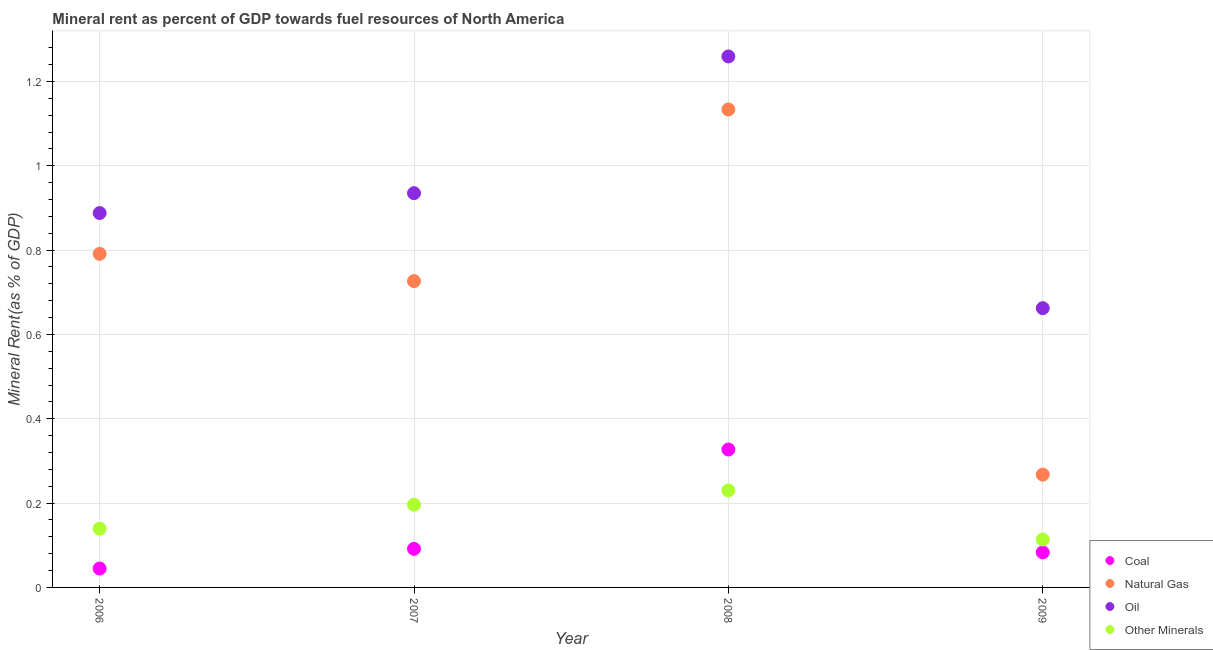What is the coal rent in 2008?
Your answer should be compact. 0.33. Across all years, what is the maximum coal rent?
Make the answer very short. 0.33. Across all years, what is the minimum  rent of other minerals?
Your response must be concise. 0.11. In which year was the natural gas rent minimum?
Keep it short and to the point. 2009. What is the total coal rent in the graph?
Provide a short and direct response. 0.55. What is the difference between the coal rent in 2006 and that in 2007?
Your answer should be very brief. -0.05. What is the difference between the coal rent in 2009 and the  rent of other minerals in 2008?
Provide a succinct answer. -0.15. What is the average coal rent per year?
Your answer should be very brief. 0.14. In the year 2009, what is the difference between the natural gas rent and oil rent?
Give a very brief answer. -0.39. In how many years, is the oil rent greater than 0.9600000000000001 %?
Your response must be concise. 1. What is the ratio of the oil rent in 2006 to that in 2009?
Your response must be concise. 1.34. Is the coal rent in 2006 less than that in 2009?
Provide a short and direct response. Yes. What is the difference between the highest and the second highest coal rent?
Ensure brevity in your answer.  0.24. What is the difference between the highest and the lowest oil rent?
Keep it short and to the point. 0.6. Is it the case that in every year, the sum of the coal rent and natural gas rent is greater than the sum of  rent of other minerals and oil rent?
Offer a terse response. No. Is it the case that in every year, the sum of the coal rent and natural gas rent is greater than the oil rent?
Your answer should be very brief. No. Is the coal rent strictly greater than the  rent of other minerals over the years?
Ensure brevity in your answer.  No. How many dotlines are there?
Ensure brevity in your answer.  4. How many years are there in the graph?
Offer a very short reply. 4. What is the title of the graph?
Make the answer very short. Mineral rent as percent of GDP towards fuel resources of North America. Does "European Union" appear as one of the legend labels in the graph?
Offer a very short reply. No. What is the label or title of the X-axis?
Your answer should be very brief. Year. What is the label or title of the Y-axis?
Provide a succinct answer. Mineral Rent(as % of GDP). What is the Mineral Rent(as % of GDP) of Coal in 2006?
Make the answer very short. 0.04. What is the Mineral Rent(as % of GDP) of Natural Gas in 2006?
Provide a short and direct response. 0.79. What is the Mineral Rent(as % of GDP) of Oil in 2006?
Ensure brevity in your answer.  0.89. What is the Mineral Rent(as % of GDP) in Other Minerals in 2006?
Make the answer very short. 0.14. What is the Mineral Rent(as % of GDP) in Coal in 2007?
Your response must be concise. 0.09. What is the Mineral Rent(as % of GDP) of Natural Gas in 2007?
Offer a very short reply. 0.73. What is the Mineral Rent(as % of GDP) of Oil in 2007?
Ensure brevity in your answer.  0.93. What is the Mineral Rent(as % of GDP) of Other Minerals in 2007?
Make the answer very short. 0.2. What is the Mineral Rent(as % of GDP) in Coal in 2008?
Offer a terse response. 0.33. What is the Mineral Rent(as % of GDP) of Natural Gas in 2008?
Give a very brief answer. 1.13. What is the Mineral Rent(as % of GDP) in Oil in 2008?
Make the answer very short. 1.26. What is the Mineral Rent(as % of GDP) of Other Minerals in 2008?
Offer a very short reply. 0.23. What is the Mineral Rent(as % of GDP) of Coal in 2009?
Provide a succinct answer. 0.08. What is the Mineral Rent(as % of GDP) of Natural Gas in 2009?
Your answer should be very brief. 0.27. What is the Mineral Rent(as % of GDP) of Oil in 2009?
Offer a terse response. 0.66. What is the Mineral Rent(as % of GDP) of Other Minerals in 2009?
Offer a terse response. 0.11. Across all years, what is the maximum Mineral Rent(as % of GDP) in Coal?
Offer a terse response. 0.33. Across all years, what is the maximum Mineral Rent(as % of GDP) in Natural Gas?
Offer a very short reply. 1.13. Across all years, what is the maximum Mineral Rent(as % of GDP) of Oil?
Your response must be concise. 1.26. Across all years, what is the maximum Mineral Rent(as % of GDP) of Other Minerals?
Offer a terse response. 0.23. Across all years, what is the minimum Mineral Rent(as % of GDP) in Coal?
Ensure brevity in your answer.  0.04. Across all years, what is the minimum Mineral Rent(as % of GDP) in Natural Gas?
Give a very brief answer. 0.27. Across all years, what is the minimum Mineral Rent(as % of GDP) of Oil?
Keep it short and to the point. 0.66. Across all years, what is the minimum Mineral Rent(as % of GDP) in Other Minerals?
Give a very brief answer. 0.11. What is the total Mineral Rent(as % of GDP) of Coal in the graph?
Your answer should be compact. 0.55. What is the total Mineral Rent(as % of GDP) in Natural Gas in the graph?
Offer a very short reply. 2.92. What is the total Mineral Rent(as % of GDP) in Oil in the graph?
Offer a very short reply. 3.74. What is the total Mineral Rent(as % of GDP) in Other Minerals in the graph?
Your response must be concise. 0.68. What is the difference between the Mineral Rent(as % of GDP) in Coal in 2006 and that in 2007?
Your response must be concise. -0.05. What is the difference between the Mineral Rent(as % of GDP) in Natural Gas in 2006 and that in 2007?
Offer a terse response. 0.06. What is the difference between the Mineral Rent(as % of GDP) of Oil in 2006 and that in 2007?
Your answer should be very brief. -0.05. What is the difference between the Mineral Rent(as % of GDP) in Other Minerals in 2006 and that in 2007?
Keep it short and to the point. -0.06. What is the difference between the Mineral Rent(as % of GDP) in Coal in 2006 and that in 2008?
Offer a very short reply. -0.28. What is the difference between the Mineral Rent(as % of GDP) in Natural Gas in 2006 and that in 2008?
Provide a short and direct response. -0.34. What is the difference between the Mineral Rent(as % of GDP) in Oil in 2006 and that in 2008?
Your response must be concise. -0.37. What is the difference between the Mineral Rent(as % of GDP) of Other Minerals in 2006 and that in 2008?
Provide a short and direct response. -0.09. What is the difference between the Mineral Rent(as % of GDP) in Coal in 2006 and that in 2009?
Your answer should be very brief. -0.04. What is the difference between the Mineral Rent(as % of GDP) in Natural Gas in 2006 and that in 2009?
Offer a very short reply. 0.52. What is the difference between the Mineral Rent(as % of GDP) of Oil in 2006 and that in 2009?
Keep it short and to the point. 0.23. What is the difference between the Mineral Rent(as % of GDP) of Other Minerals in 2006 and that in 2009?
Give a very brief answer. 0.03. What is the difference between the Mineral Rent(as % of GDP) in Coal in 2007 and that in 2008?
Offer a terse response. -0.24. What is the difference between the Mineral Rent(as % of GDP) in Natural Gas in 2007 and that in 2008?
Your answer should be compact. -0.41. What is the difference between the Mineral Rent(as % of GDP) in Oil in 2007 and that in 2008?
Provide a succinct answer. -0.32. What is the difference between the Mineral Rent(as % of GDP) in Other Minerals in 2007 and that in 2008?
Offer a very short reply. -0.03. What is the difference between the Mineral Rent(as % of GDP) in Coal in 2007 and that in 2009?
Keep it short and to the point. 0.01. What is the difference between the Mineral Rent(as % of GDP) of Natural Gas in 2007 and that in 2009?
Provide a succinct answer. 0.46. What is the difference between the Mineral Rent(as % of GDP) in Oil in 2007 and that in 2009?
Give a very brief answer. 0.27. What is the difference between the Mineral Rent(as % of GDP) in Other Minerals in 2007 and that in 2009?
Make the answer very short. 0.08. What is the difference between the Mineral Rent(as % of GDP) of Coal in 2008 and that in 2009?
Provide a succinct answer. 0.24. What is the difference between the Mineral Rent(as % of GDP) of Natural Gas in 2008 and that in 2009?
Give a very brief answer. 0.87. What is the difference between the Mineral Rent(as % of GDP) in Oil in 2008 and that in 2009?
Make the answer very short. 0.6. What is the difference between the Mineral Rent(as % of GDP) of Other Minerals in 2008 and that in 2009?
Offer a very short reply. 0.12. What is the difference between the Mineral Rent(as % of GDP) of Coal in 2006 and the Mineral Rent(as % of GDP) of Natural Gas in 2007?
Give a very brief answer. -0.68. What is the difference between the Mineral Rent(as % of GDP) in Coal in 2006 and the Mineral Rent(as % of GDP) in Oil in 2007?
Offer a very short reply. -0.89. What is the difference between the Mineral Rent(as % of GDP) in Coal in 2006 and the Mineral Rent(as % of GDP) in Other Minerals in 2007?
Your response must be concise. -0.15. What is the difference between the Mineral Rent(as % of GDP) of Natural Gas in 2006 and the Mineral Rent(as % of GDP) of Oil in 2007?
Your answer should be compact. -0.14. What is the difference between the Mineral Rent(as % of GDP) in Natural Gas in 2006 and the Mineral Rent(as % of GDP) in Other Minerals in 2007?
Offer a very short reply. 0.59. What is the difference between the Mineral Rent(as % of GDP) of Oil in 2006 and the Mineral Rent(as % of GDP) of Other Minerals in 2007?
Make the answer very short. 0.69. What is the difference between the Mineral Rent(as % of GDP) in Coal in 2006 and the Mineral Rent(as % of GDP) in Natural Gas in 2008?
Ensure brevity in your answer.  -1.09. What is the difference between the Mineral Rent(as % of GDP) of Coal in 2006 and the Mineral Rent(as % of GDP) of Oil in 2008?
Ensure brevity in your answer.  -1.21. What is the difference between the Mineral Rent(as % of GDP) of Coal in 2006 and the Mineral Rent(as % of GDP) of Other Minerals in 2008?
Your answer should be compact. -0.19. What is the difference between the Mineral Rent(as % of GDP) in Natural Gas in 2006 and the Mineral Rent(as % of GDP) in Oil in 2008?
Your response must be concise. -0.47. What is the difference between the Mineral Rent(as % of GDP) of Natural Gas in 2006 and the Mineral Rent(as % of GDP) of Other Minerals in 2008?
Give a very brief answer. 0.56. What is the difference between the Mineral Rent(as % of GDP) in Oil in 2006 and the Mineral Rent(as % of GDP) in Other Minerals in 2008?
Give a very brief answer. 0.66. What is the difference between the Mineral Rent(as % of GDP) in Coal in 2006 and the Mineral Rent(as % of GDP) in Natural Gas in 2009?
Offer a very short reply. -0.22. What is the difference between the Mineral Rent(as % of GDP) in Coal in 2006 and the Mineral Rent(as % of GDP) in Oil in 2009?
Offer a terse response. -0.62. What is the difference between the Mineral Rent(as % of GDP) in Coal in 2006 and the Mineral Rent(as % of GDP) in Other Minerals in 2009?
Give a very brief answer. -0.07. What is the difference between the Mineral Rent(as % of GDP) of Natural Gas in 2006 and the Mineral Rent(as % of GDP) of Oil in 2009?
Provide a short and direct response. 0.13. What is the difference between the Mineral Rent(as % of GDP) of Natural Gas in 2006 and the Mineral Rent(as % of GDP) of Other Minerals in 2009?
Offer a terse response. 0.68. What is the difference between the Mineral Rent(as % of GDP) in Oil in 2006 and the Mineral Rent(as % of GDP) in Other Minerals in 2009?
Your answer should be compact. 0.77. What is the difference between the Mineral Rent(as % of GDP) in Coal in 2007 and the Mineral Rent(as % of GDP) in Natural Gas in 2008?
Your response must be concise. -1.04. What is the difference between the Mineral Rent(as % of GDP) in Coal in 2007 and the Mineral Rent(as % of GDP) in Oil in 2008?
Keep it short and to the point. -1.17. What is the difference between the Mineral Rent(as % of GDP) in Coal in 2007 and the Mineral Rent(as % of GDP) in Other Minerals in 2008?
Your answer should be very brief. -0.14. What is the difference between the Mineral Rent(as % of GDP) of Natural Gas in 2007 and the Mineral Rent(as % of GDP) of Oil in 2008?
Provide a succinct answer. -0.53. What is the difference between the Mineral Rent(as % of GDP) of Natural Gas in 2007 and the Mineral Rent(as % of GDP) of Other Minerals in 2008?
Give a very brief answer. 0.5. What is the difference between the Mineral Rent(as % of GDP) in Oil in 2007 and the Mineral Rent(as % of GDP) in Other Minerals in 2008?
Your answer should be compact. 0.7. What is the difference between the Mineral Rent(as % of GDP) in Coal in 2007 and the Mineral Rent(as % of GDP) in Natural Gas in 2009?
Provide a succinct answer. -0.18. What is the difference between the Mineral Rent(as % of GDP) of Coal in 2007 and the Mineral Rent(as % of GDP) of Oil in 2009?
Offer a very short reply. -0.57. What is the difference between the Mineral Rent(as % of GDP) of Coal in 2007 and the Mineral Rent(as % of GDP) of Other Minerals in 2009?
Keep it short and to the point. -0.02. What is the difference between the Mineral Rent(as % of GDP) of Natural Gas in 2007 and the Mineral Rent(as % of GDP) of Oil in 2009?
Offer a very short reply. 0.06. What is the difference between the Mineral Rent(as % of GDP) of Natural Gas in 2007 and the Mineral Rent(as % of GDP) of Other Minerals in 2009?
Your answer should be very brief. 0.61. What is the difference between the Mineral Rent(as % of GDP) of Oil in 2007 and the Mineral Rent(as % of GDP) of Other Minerals in 2009?
Offer a terse response. 0.82. What is the difference between the Mineral Rent(as % of GDP) in Coal in 2008 and the Mineral Rent(as % of GDP) in Natural Gas in 2009?
Make the answer very short. 0.06. What is the difference between the Mineral Rent(as % of GDP) of Coal in 2008 and the Mineral Rent(as % of GDP) of Oil in 2009?
Offer a very short reply. -0.34. What is the difference between the Mineral Rent(as % of GDP) in Coal in 2008 and the Mineral Rent(as % of GDP) in Other Minerals in 2009?
Offer a very short reply. 0.21. What is the difference between the Mineral Rent(as % of GDP) of Natural Gas in 2008 and the Mineral Rent(as % of GDP) of Oil in 2009?
Give a very brief answer. 0.47. What is the difference between the Mineral Rent(as % of GDP) of Natural Gas in 2008 and the Mineral Rent(as % of GDP) of Other Minerals in 2009?
Offer a very short reply. 1.02. What is the difference between the Mineral Rent(as % of GDP) in Oil in 2008 and the Mineral Rent(as % of GDP) in Other Minerals in 2009?
Provide a succinct answer. 1.15. What is the average Mineral Rent(as % of GDP) of Coal per year?
Provide a succinct answer. 0.14. What is the average Mineral Rent(as % of GDP) of Natural Gas per year?
Keep it short and to the point. 0.73. What is the average Mineral Rent(as % of GDP) in Oil per year?
Your answer should be very brief. 0.94. What is the average Mineral Rent(as % of GDP) in Other Minerals per year?
Offer a terse response. 0.17. In the year 2006, what is the difference between the Mineral Rent(as % of GDP) of Coal and Mineral Rent(as % of GDP) of Natural Gas?
Your answer should be very brief. -0.75. In the year 2006, what is the difference between the Mineral Rent(as % of GDP) in Coal and Mineral Rent(as % of GDP) in Oil?
Your answer should be very brief. -0.84. In the year 2006, what is the difference between the Mineral Rent(as % of GDP) in Coal and Mineral Rent(as % of GDP) in Other Minerals?
Ensure brevity in your answer.  -0.09. In the year 2006, what is the difference between the Mineral Rent(as % of GDP) of Natural Gas and Mineral Rent(as % of GDP) of Oil?
Your answer should be compact. -0.1. In the year 2006, what is the difference between the Mineral Rent(as % of GDP) of Natural Gas and Mineral Rent(as % of GDP) of Other Minerals?
Your answer should be compact. 0.65. In the year 2006, what is the difference between the Mineral Rent(as % of GDP) of Oil and Mineral Rent(as % of GDP) of Other Minerals?
Offer a terse response. 0.75. In the year 2007, what is the difference between the Mineral Rent(as % of GDP) of Coal and Mineral Rent(as % of GDP) of Natural Gas?
Keep it short and to the point. -0.63. In the year 2007, what is the difference between the Mineral Rent(as % of GDP) of Coal and Mineral Rent(as % of GDP) of Oil?
Your answer should be very brief. -0.84. In the year 2007, what is the difference between the Mineral Rent(as % of GDP) in Coal and Mineral Rent(as % of GDP) in Other Minerals?
Offer a terse response. -0.1. In the year 2007, what is the difference between the Mineral Rent(as % of GDP) of Natural Gas and Mineral Rent(as % of GDP) of Oil?
Keep it short and to the point. -0.21. In the year 2007, what is the difference between the Mineral Rent(as % of GDP) in Natural Gas and Mineral Rent(as % of GDP) in Other Minerals?
Offer a very short reply. 0.53. In the year 2007, what is the difference between the Mineral Rent(as % of GDP) in Oil and Mineral Rent(as % of GDP) in Other Minerals?
Your response must be concise. 0.74. In the year 2008, what is the difference between the Mineral Rent(as % of GDP) in Coal and Mineral Rent(as % of GDP) in Natural Gas?
Ensure brevity in your answer.  -0.81. In the year 2008, what is the difference between the Mineral Rent(as % of GDP) of Coal and Mineral Rent(as % of GDP) of Oil?
Offer a terse response. -0.93. In the year 2008, what is the difference between the Mineral Rent(as % of GDP) of Coal and Mineral Rent(as % of GDP) of Other Minerals?
Ensure brevity in your answer.  0.1. In the year 2008, what is the difference between the Mineral Rent(as % of GDP) of Natural Gas and Mineral Rent(as % of GDP) of Oil?
Keep it short and to the point. -0.13. In the year 2008, what is the difference between the Mineral Rent(as % of GDP) in Natural Gas and Mineral Rent(as % of GDP) in Other Minerals?
Keep it short and to the point. 0.9. In the year 2008, what is the difference between the Mineral Rent(as % of GDP) in Oil and Mineral Rent(as % of GDP) in Other Minerals?
Your answer should be compact. 1.03. In the year 2009, what is the difference between the Mineral Rent(as % of GDP) of Coal and Mineral Rent(as % of GDP) of Natural Gas?
Offer a very short reply. -0.18. In the year 2009, what is the difference between the Mineral Rent(as % of GDP) in Coal and Mineral Rent(as % of GDP) in Oil?
Keep it short and to the point. -0.58. In the year 2009, what is the difference between the Mineral Rent(as % of GDP) in Coal and Mineral Rent(as % of GDP) in Other Minerals?
Provide a short and direct response. -0.03. In the year 2009, what is the difference between the Mineral Rent(as % of GDP) in Natural Gas and Mineral Rent(as % of GDP) in Oil?
Your response must be concise. -0.39. In the year 2009, what is the difference between the Mineral Rent(as % of GDP) of Natural Gas and Mineral Rent(as % of GDP) of Other Minerals?
Offer a terse response. 0.15. In the year 2009, what is the difference between the Mineral Rent(as % of GDP) in Oil and Mineral Rent(as % of GDP) in Other Minerals?
Keep it short and to the point. 0.55. What is the ratio of the Mineral Rent(as % of GDP) in Coal in 2006 to that in 2007?
Your answer should be very brief. 0.49. What is the ratio of the Mineral Rent(as % of GDP) in Natural Gas in 2006 to that in 2007?
Make the answer very short. 1.09. What is the ratio of the Mineral Rent(as % of GDP) in Oil in 2006 to that in 2007?
Give a very brief answer. 0.95. What is the ratio of the Mineral Rent(as % of GDP) of Other Minerals in 2006 to that in 2007?
Keep it short and to the point. 0.71. What is the ratio of the Mineral Rent(as % of GDP) of Coal in 2006 to that in 2008?
Provide a succinct answer. 0.14. What is the ratio of the Mineral Rent(as % of GDP) of Natural Gas in 2006 to that in 2008?
Provide a short and direct response. 0.7. What is the ratio of the Mineral Rent(as % of GDP) in Oil in 2006 to that in 2008?
Provide a succinct answer. 0.7. What is the ratio of the Mineral Rent(as % of GDP) in Other Minerals in 2006 to that in 2008?
Keep it short and to the point. 0.61. What is the ratio of the Mineral Rent(as % of GDP) of Coal in 2006 to that in 2009?
Give a very brief answer. 0.54. What is the ratio of the Mineral Rent(as % of GDP) in Natural Gas in 2006 to that in 2009?
Your answer should be compact. 2.96. What is the ratio of the Mineral Rent(as % of GDP) in Oil in 2006 to that in 2009?
Provide a succinct answer. 1.34. What is the ratio of the Mineral Rent(as % of GDP) in Other Minerals in 2006 to that in 2009?
Offer a very short reply. 1.23. What is the ratio of the Mineral Rent(as % of GDP) in Coal in 2007 to that in 2008?
Give a very brief answer. 0.28. What is the ratio of the Mineral Rent(as % of GDP) in Natural Gas in 2007 to that in 2008?
Make the answer very short. 0.64. What is the ratio of the Mineral Rent(as % of GDP) of Oil in 2007 to that in 2008?
Give a very brief answer. 0.74. What is the ratio of the Mineral Rent(as % of GDP) of Other Minerals in 2007 to that in 2008?
Make the answer very short. 0.85. What is the ratio of the Mineral Rent(as % of GDP) in Coal in 2007 to that in 2009?
Offer a very short reply. 1.1. What is the ratio of the Mineral Rent(as % of GDP) of Natural Gas in 2007 to that in 2009?
Give a very brief answer. 2.71. What is the ratio of the Mineral Rent(as % of GDP) of Oil in 2007 to that in 2009?
Your answer should be very brief. 1.41. What is the ratio of the Mineral Rent(as % of GDP) of Other Minerals in 2007 to that in 2009?
Give a very brief answer. 1.73. What is the ratio of the Mineral Rent(as % of GDP) of Coal in 2008 to that in 2009?
Give a very brief answer. 3.93. What is the ratio of the Mineral Rent(as % of GDP) of Natural Gas in 2008 to that in 2009?
Ensure brevity in your answer.  4.24. What is the ratio of the Mineral Rent(as % of GDP) in Oil in 2008 to that in 2009?
Offer a very short reply. 1.9. What is the ratio of the Mineral Rent(as % of GDP) in Other Minerals in 2008 to that in 2009?
Your answer should be very brief. 2.02. What is the difference between the highest and the second highest Mineral Rent(as % of GDP) in Coal?
Your answer should be compact. 0.24. What is the difference between the highest and the second highest Mineral Rent(as % of GDP) in Natural Gas?
Ensure brevity in your answer.  0.34. What is the difference between the highest and the second highest Mineral Rent(as % of GDP) in Oil?
Offer a very short reply. 0.32. What is the difference between the highest and the second highest Mineral Rent(as % of GDP) in Other Minerals?
Your answer should be compact. 0.03. What is the difference between the highest and the lowest Mineral Rent(as % of GDP) of Coal?
Your answer should be compact. 0.28. What is the difference between the highest and the lowest Mineral Rent(as % of GDP) in Natural Gas?
Your answer should be compact. 0.87. What is the difference between the highest and the lowest Mineral Rent(as % of GDP) of Oil?
Provide a short and direct response. 0.6. What is the difference between the highest and the lowest Mineral Rent(as % of GDP) in Other Minerals?
Offer a very short reply. 0.12. 